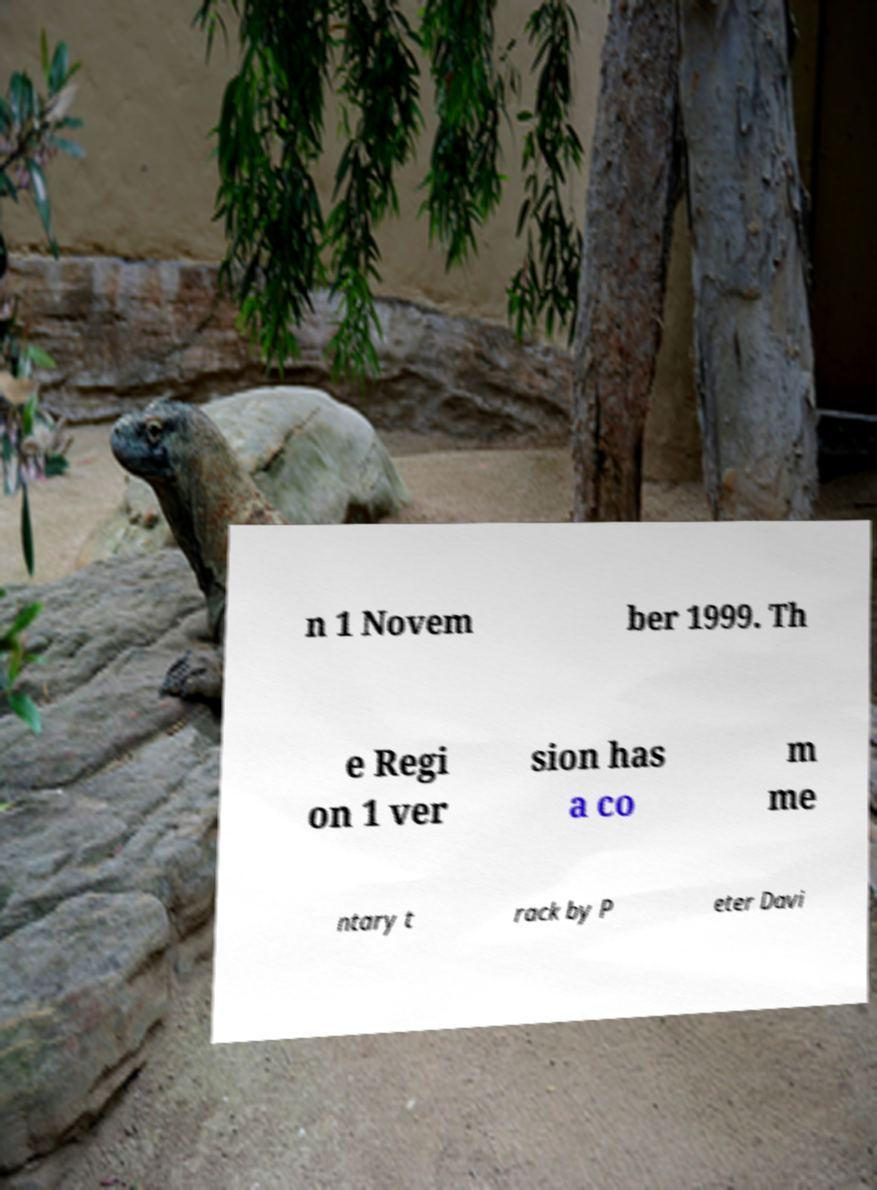Please identify and transcribe the text found in this image. n 1 Novem ber 1999. Th e Regi on 1 ver sion has a co m me ntary t rack by P eter Davi 